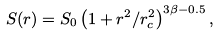<formula> <loc_0><loc_0><loc_500><loc_500>S ( r ) = S _ { 0 } \left ( 1 + r ^ { 2 } / r _ { c } ^ { 2 } \right ) ^ { 3 \beta - 0 . 5 } ,</formula> 